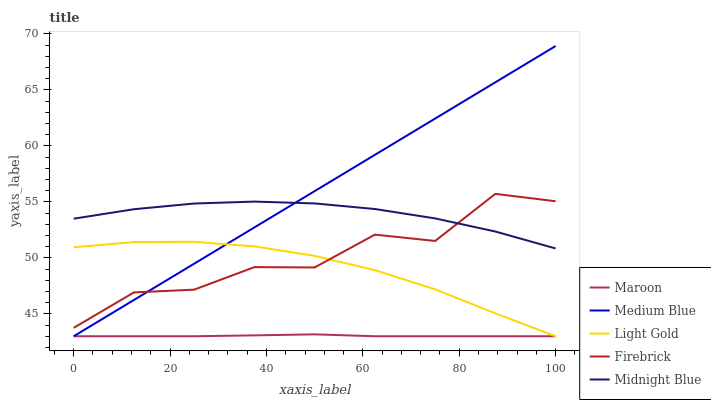Does Maroon have the minimum area under the curve?
Answer yes or no. Yes. Does Medium Blue have the maximum area under the curve?
Answer yes or no. Yes. Does Firebrick have the minimum area under the curve?
Answer yes or no. No. Does Firebrick have the maximum area under the curve?
Answer yes or no. No. Is Medium Blue the smoothest?
Answer yes or no. Yes. Is Firebrick the roughest?
Answer yes or no. Yes. Is Firebrick the smoothest?
Answer yes or no. No. Is Medium Blue the roughest?
Answer yes or no. No. Does Light Gold have the lowest value?
Answer yes or no. Yes. Does Firebrick have the lowest value?
Answer yes or no. No. Does Medium Blue have the highest value?
Answer yes or no. Yes. Does Firebrick have the highest value?
Answer yes or no. No. Is Maroon less than Firebrick?
Answer yes or no. Yes. Is Firebrick greater than Maroon?
Answer yes or no. Yes. Does Light Gold intersect Medium Blue?
Answer yes or no. Yes. Is Light Gold less than Medium Blue?
Answer yes or no. No. Is Light Gold greater than Medium Blue?
Answer yes or no. No. Does Maroon intersect Firebrick?
Answer yes or no. No. 